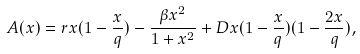Convert formula to latex. <formula><loc_0><loc_0><loc_500><loc_500>A ( x ) = r x ( 1 - \frac { x } { q } ) - \frac { \beta x ^ { 2 } } { 1 + x ^ { 2 } } + D x ( 1 - \frac { x } { q } ) ( 1 - \frac { 2 x } { q } ) ,</formula> 